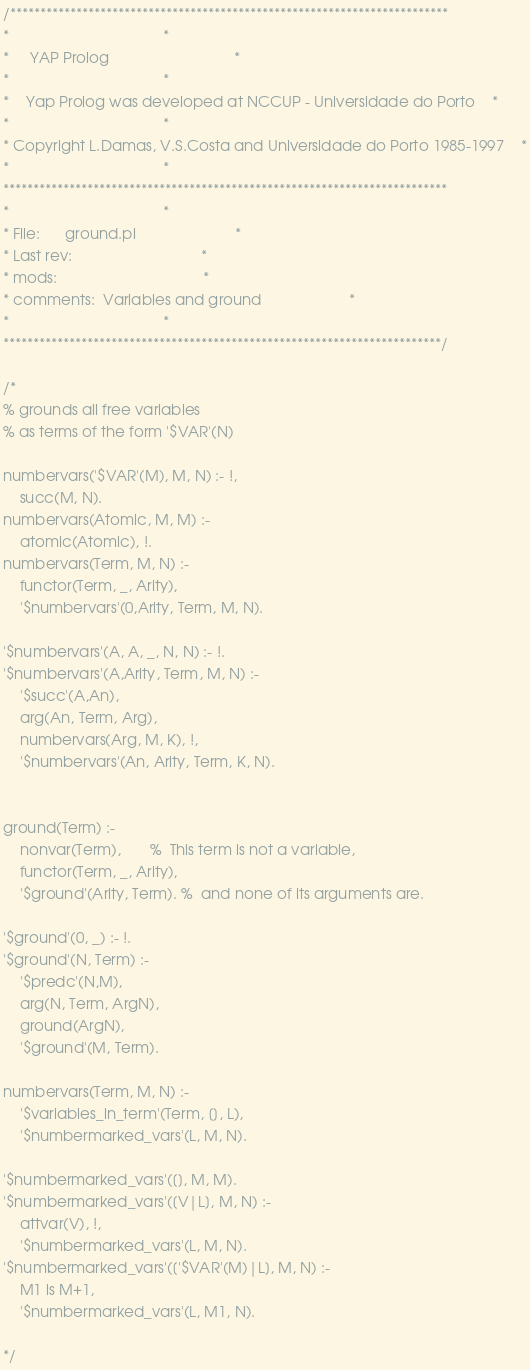<code> <loc_0><loc_0><loc_500><loc_500><_Prolog_>/*************************************************************************
*									 *
*	 YAP Prolog 							 *
*									 *
*	Yap Prolog was developed at NCCUP - Universidade do Porto	 *
*									 *
* Copyright L.Damas, V.S.Costa and Universidade do Porto 1985-1997	 *
*									 *
**************************************************************************
*									 *
* File:		ground.pl						 *
* Last rev:								 *
* mods:									 *
* comments:	Variables and ground					 *
*									 *
*************************************************************************/

/*
% grounds all free variables
% as terms of the form '$VAR'(N)

numbervars('$VAR'(M), M, N) :- !,
	succ(M, N).
numbervars(Atomic, M, M) :-
	atomic(Atomic), !.
numbervars(Term, M, N) :-
	functor(Term, _, Arity),
	'$numbervars'(0,Arity, Term, M, N).

'$numbervars'(A, A, _, N, N) :- !.
'$numbervars'(A,Arity, Term, M, N) :-
	'$succ'(A,An),
	arg(An, Term, Arg),
	numbervars(Arg, M, K), !,
	'$numbervars'(An, Arity, Term, K, N).


ground(Term) :-
	nonvar(Term),		%  This term is not a variable,
	functor(Term, _, Arity),
	'$ground'(Arity, Term).	%  and none of its arguments are.

'$ground'(0, _) :- !.
'$ground'(N, Term) :-
	'$predc'(N,M),
	arg(N, Term, ArgN),
	ground(ArgN),
	'$ground'(M, Term).

numbervars(Term, M, N) :-
	'$variables_in_term'(Term, [], L),
	'$numbermarked_vars'(L, M, N).

'$numbermarked_vars'([], M, M).
'$numbermarked_vars'([V|L], M, N) :- 
	attvar(V), !,
	'$numbermarked_vars'(L, M, N).
'$numbermarked_vars'(['$VAR'(M)|L], M, N) :-
	M1 is M+1,
	'$numbermarked_vars'(L, M1, N).

*/

</code> 